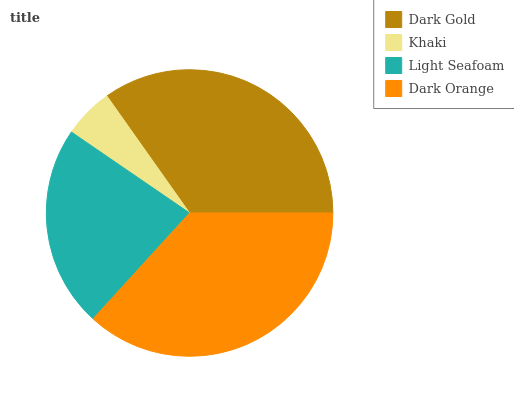Is Khaki the minimum?
Answer yes or no. Yes. Is Dark Orange the maximum?
Answer yes or no. Yes. Is Light Seafoam the minimum?
Answer yes or no. No. Is Light Seafoam the maximum?
Answer yes or no. No. Is Light Seafoam greater than Khaki?
Answer yes or no. Yes. Is Khaki less than Light Seafoam?
Answer yes or no. Yes. Is Khaki greater than Light Seafoam?
Answer yes or no. No. Is Light Seafoam less than Khaki?
Answer yes or no. No. Is Dark Gold the high median?
Answer yes or no. Yes. Is Light Seafoam the low median?
Answer yes or no. Yes. Is Light Seafoam the high median?
Answer yes or no. No. Is Dark Orange the low median?
Answer yes or no. No. 